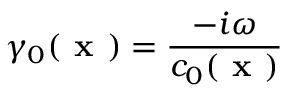<formula> <loc_0><loc_0><loc_500><loc_500>\gamma _ { 0 } ( x ) = \frac { - i \omega } { c _ { 0 } ( x ) }</formula> 